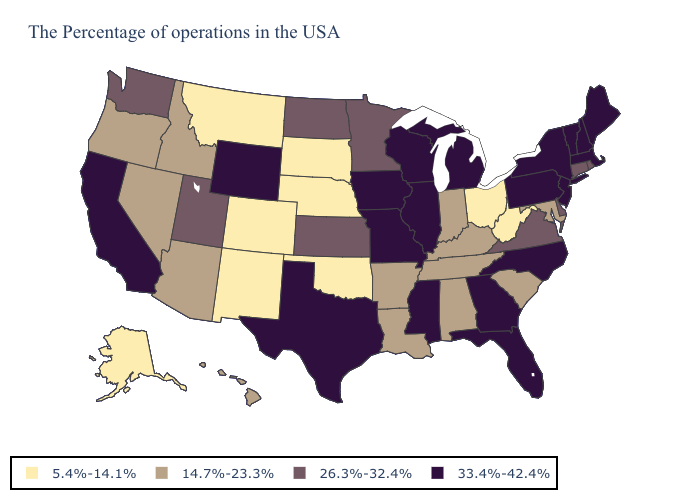Name the states that have a value in the range 14.7%-23.3%?
Concise answer only. Maryland, South Carolina, Kentucky, Indiana, Alabama, Tennessee, Louisiana, Arkansas, Arizona, Idaho, Nevada, Oregon, Hawaii. Among the states that border Oklahoma , which have the lowest value?
Be succinct. Colorado, New Mexico. Among the states that border Nebraska , which have the highest value?
Answer briefly. Missouri, Iowa, Wyoming. Does Pennsylvania have the highest value in the USA?
Keep it brief. Yes. Does Connecticut have a higher value than Ohio?
Answer briefly. Yes. What is the highest value in states that border Nevada?
Short answer required. 33.4%-42.4%. What is the value of Texas?
Concise answer only. 33.4%-42.4%. Does Kansas have the same value as Colorado?
Give a very brief answer. No. What is the value of Mississippi?
Give a very brief answer. 33.4%-42.4%. Which states hav the highest value in the MidWest?
Keep it brief. Michigan, Wisconsin, Illinois, Missouri, Iowa. Name the states that have a value in the range 5.4%-14.1%?
Be succinct. West Virginia, Ohio, Nebraska, Oklahoma, South Dakota, Colorado, New Mexico, Montana, Alaska. What is the lowest value in the Northeast?
Keep it brief. 26.3%-32.4%. How many symbols are there in the legend?
Concise answer only. 4. What is the highest value in states that border Missouri?
Concise answer only. 33.4%-42.4%. 